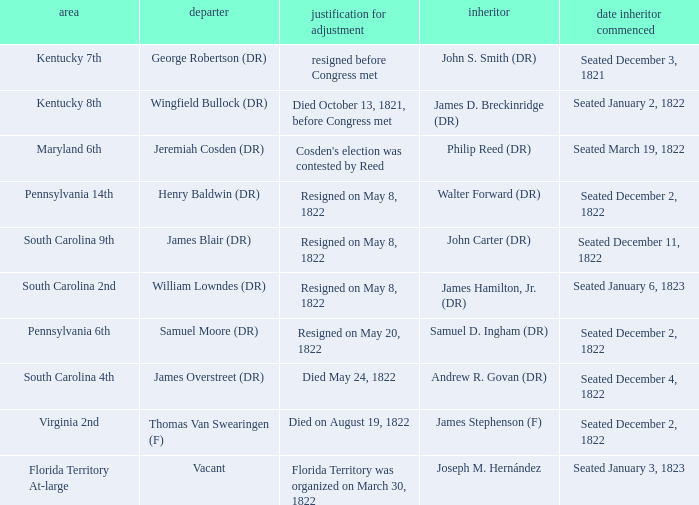What is the reason for change when maryland 6th is the district?  Cosden's election was contested by Reed. 